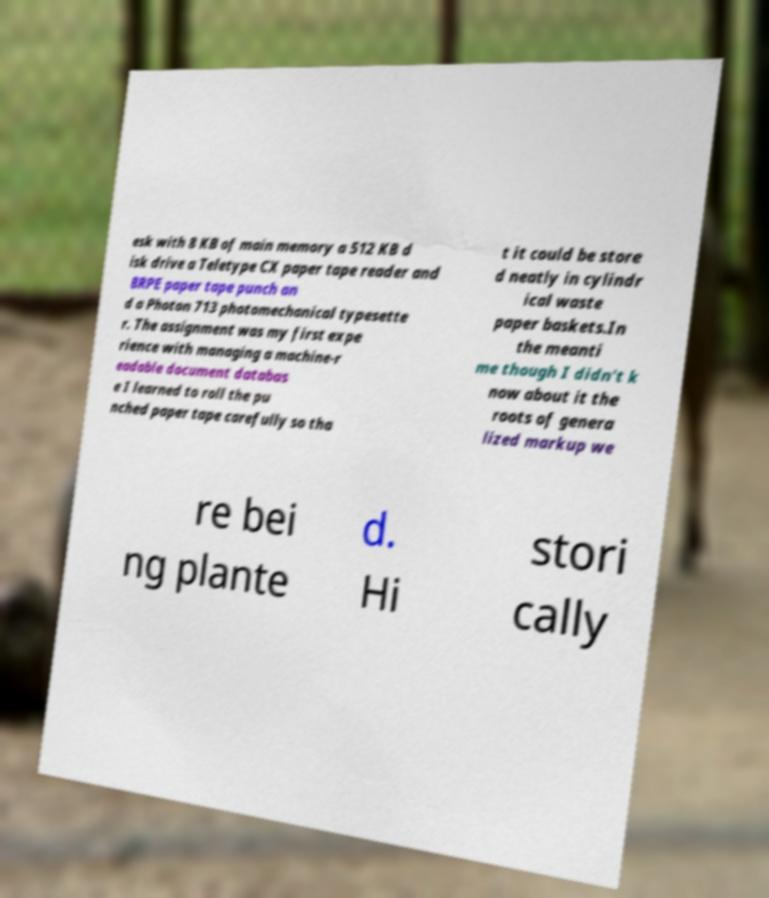There's text embedded in this image that I need extracted. Can you transcribe it verbatim? esk with 8 KB of main memory a 512 KB d isk drive a Teletype CX paper tape reader and BRPE paper tape punch an d a Photon 713 photomechanical typesette r. The assignment was my first expe rience with managing a machine-r eadable document databas e I learned to roll the pu nched paper tape carefully so tha t it could be store d neatly in cylindr ical waste paper baskets.In the meanti me though I didn't k now about it the roots of genera lized markup we re bei ng plante d. Hi stori cally 